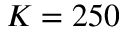Convert formula to latex. <formula><loc_0><loc_0><loc_500><loc_500>K = 2 5 0</formula> 